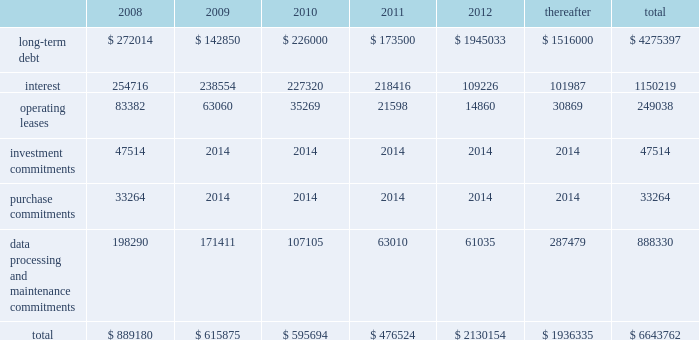Our existing cash flow hedges are highly effective and there is no current impact on earnings due to hedge ineffectiveness .
It is our policy to execute such instruments with credit-worthy banks and not to enter into derivative financial instruments for speculative purposes .
Contractual obligations fis 2019s long-term contractual obligations generally include its long-term debt and operating lease payments on certain of its property and equipment .
The table summarizes fis 2019s significant contractual obligations and commitments as of december 31 , 2007 ( in thousands ) : .
Off-balance sheet arrangements fis does not have any material off-balance sheet arrangements other than operating leases .
Escrow arrangements in conducting our title agency , closing and 1031 exchange services operations , we routinely hold customers 2019 assets in escrow , pending completion of real estate transactions .
Certain of these amounts are maintained in segregated bank accounts and have not been included in the accompanying consolidated balance sheets .
We have a contingent liability relating to proper disposition of these balances , which amounted to $ 1926.8 million at december 31 , 2007 .
As a result of holding these customers 2019 assets in escrow , we have ongoing programs for realizing economic benefits during the year through favorable borrowing and vendor arrangements with various banks .
There were no loans outstanding as of december 31 , 2007 and these balances were invested in short term , high grade investments that minimize the risk to principal .
Recent accounting pronouncements in december 2007 , the fasb issued sfas no .
141 ( revised 2007 ) , business combinations ( 201csfas 141 ( r ) 201d ) , requiring an acquirer in a business combination to recognize the assets acquired , the liabilities assumed , and any noncontrolling interest in the acquiree at their fair values at the acquisition date , with limited exceptions .
The costs of the acquisition and any related restructuring costs will be recognized separately .
Assets and liabilities arising from contingencies in a business combination are to be recognized at their fair value at the acquisition date and adjusted prospectively as new information becomes available .
When the fair value of assets acquired exceeds the fair value of consideration transferred plus any noncontrolling interest in the acquiree , the excess will be recognized as a gain .
Under sfas 141 ( r ) , all business combinations will be accounted for by applying the acquisition method , including combinations among mutual entities and combinations by contract alone .
Sfas 141 ( r ) applies prospectively to business combinations for which the acquisition date is on or after the first annual reporting period beginning on or after december 15 , 2008 , is effective for periods beginning on or after december 15 , 2008 , and will apply to business combinations occurring after the effective date .
Management is currently evaluating the impact of this statement on our statements of financial position and operations .
In december 2007 , the fasb issued sfas no .
160 , noncontrolling interests in consolidated financial statements 2014 an amendment of arb no .
51 ( 201csfas 160 201d ) , requiring noncontrolling interests ( sometimes called minority interests ) to be presented as a component of equity on the balance sheet .
Sfas 160 also requires that the amount of net income attributable to the parent and to the noncontrolling interests be clearly identified and presented on the face of the consolidated statement of income .
This statement eliminates the need to apply purchase .
What portion of the operating leases are due in the next 12 months? 
Computations: (83382 / 249038)
Answer: 0.33482. 